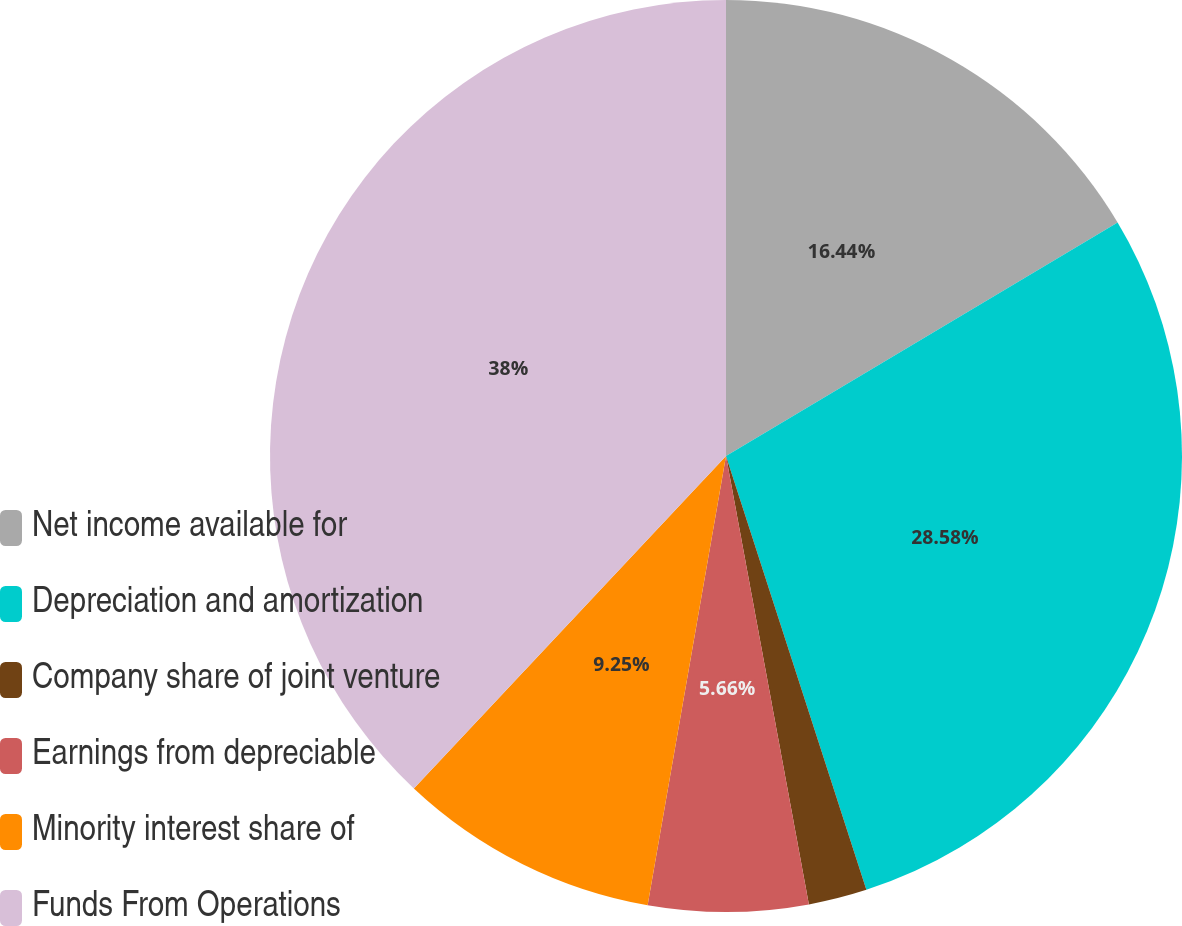Convert chart to OTSL. <chart><loc_0><loc_0><loc_500><loc_500><pie_chart><fcel>Net income available for<fcel>Depreciation and amortization<fcel>Company share of joint venture<fcel>Earnings from depreciable<fcel>Minority interest share of<fcel>Funds From Operations<nl><fcel>16.44%<fcel>28.58%<fcel>2.07%<fcel>5.66%<fcel>9.25%<fcel>38.0%<nl></chart> 